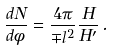Convert formula to latex. <formula><loc_0><loc_0><loc_500><loc_500>\frac { d N } { d \phi } = \frac { 4 \pi } { \mp l ^ { 2 } } \frac { H } { H ^ { \prime } } \, .</formula> 